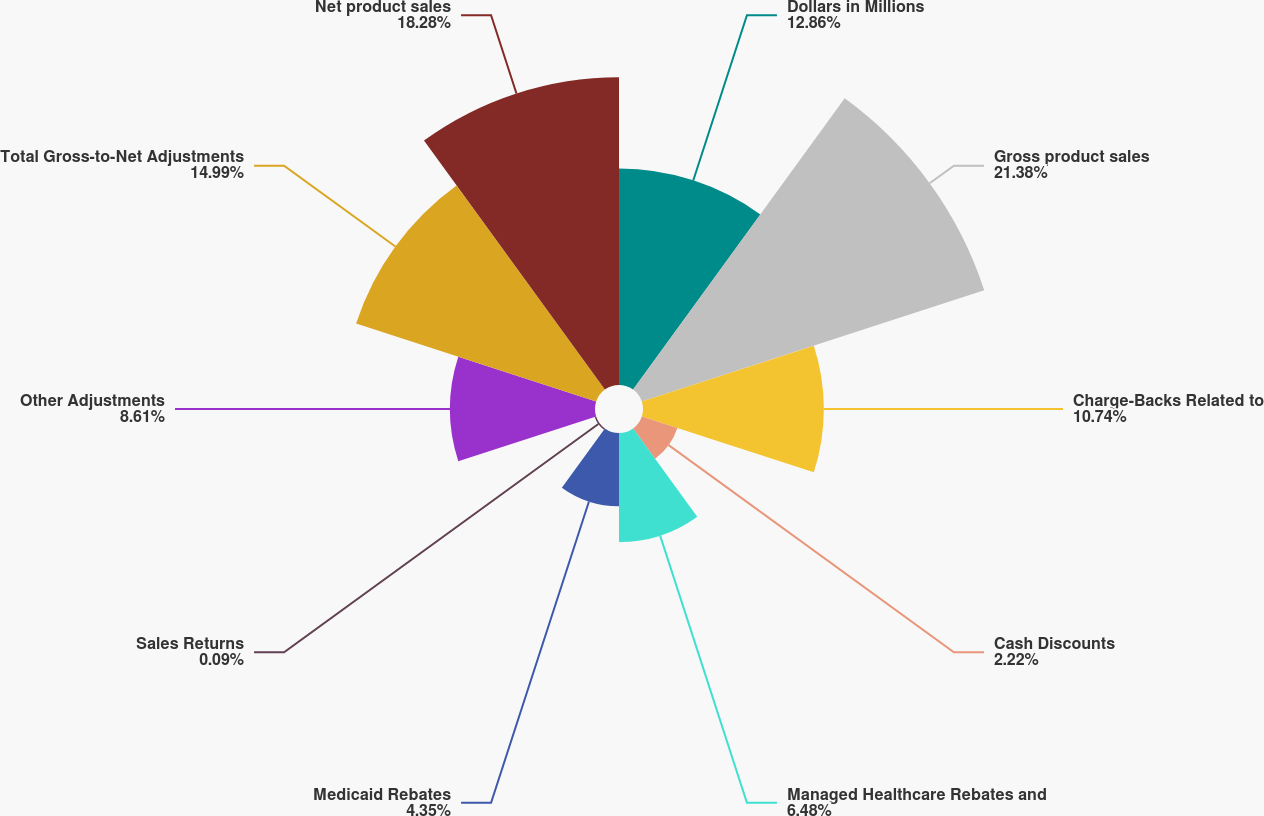Convert chart. <chart><loc_0><loc_0><loc_500><loc_500><pie_chart><fcel>Dollars in Millions<fcel>Gross product sales<fcel>Charge-Backs Related to<fcel>Cash Discounts<fcel>Managed Healthcare Rebates and<fcel>Medicaid Rebates<fcel>Sales Returns<fcel>Other Adjustments<fcel>Total Gross-to-Net Adjustments<fcel>Net product sales<nl><fcel>12.86%<fcel>21.38%<fcel>10.74%<fcel>2.22%<fcel>6.48%<fcel>4.35%<fcel>0.09%<fcel>8.61%<fcel>14.99%<fcel>18.28%<nl></chart> 